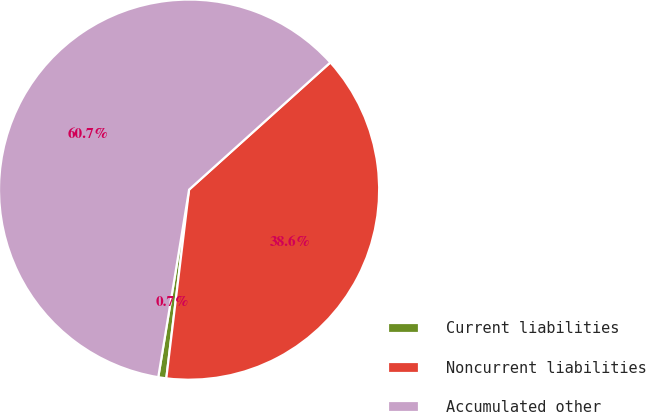Convert chart to OTSL. <chart><loc_0><loc_0><loc_500><loc_500><pie_chart><fcel>Current liabilities<fcel>Noncurrent liabilities<fcel>Accumulated other<nl><fcel>0.68%<fcel>38.58%<fcel>60.74%<nl></chart> 